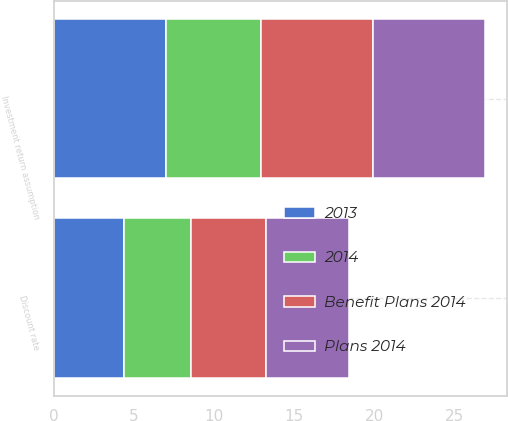Convert chart. <chart><loc_0><loc_0><loc_500><loc_500><stacked_bar_chart><ecel><fcel>Discount rate<fcel>Investment return assumption<nl><fcel>Plans 2014<fcel>5.15<fcel>7<nl><fcel>2013<fcel>4.35<fcel>7<nl><fcel>2014<fcel>4.24<fcel>5.92<nl><fcel>Benefit Plans 2014<fcel>4.65<fcel>7<nl></chart> 